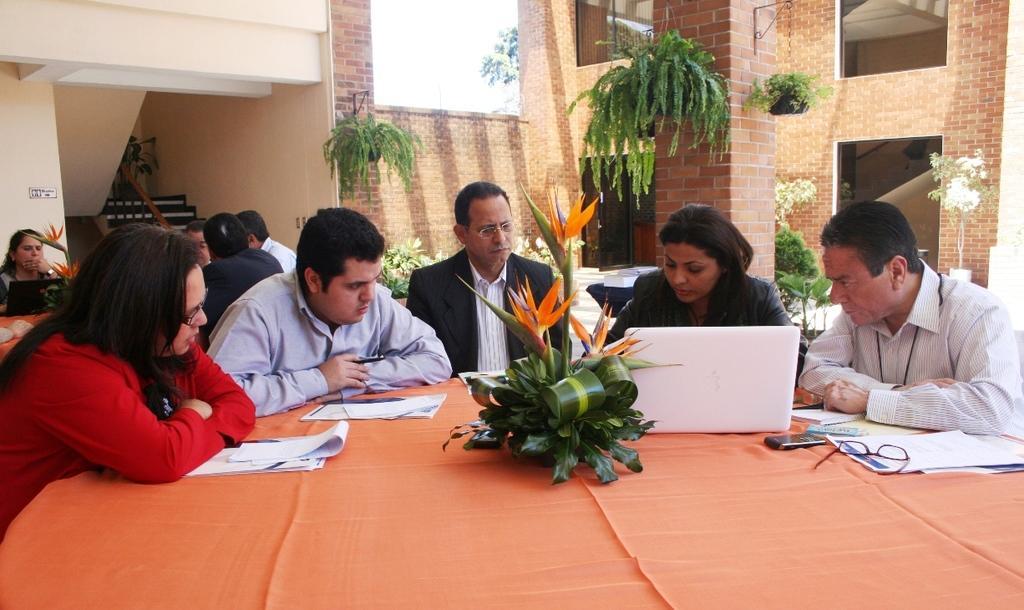Describe this image in one or two sentences. In this image we can see few people sitting on chairs. There are a few objects and tables. Behind the persons we can see the wall and houseplants. On the wall we can see the window. At the top we can see the sky and a tree. In the top left, we can see the stairs. 